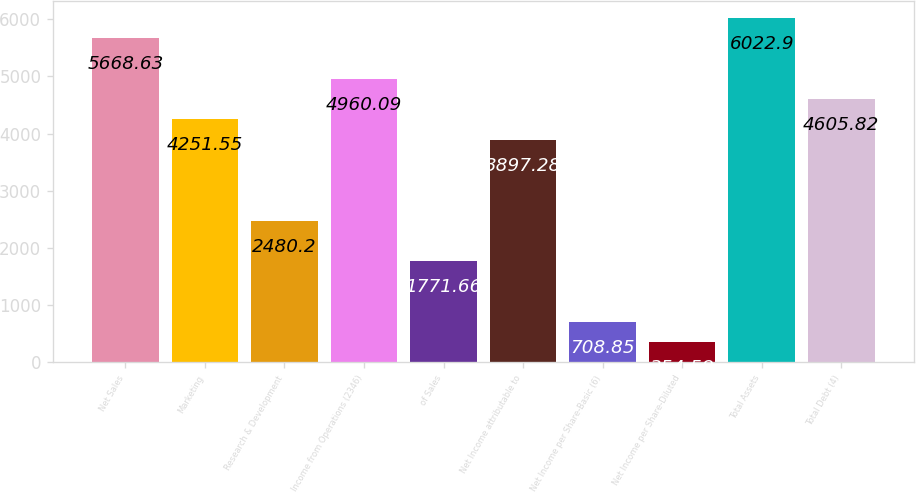<chart> <loc_0><loc_0><loc_500><loc_500><bar_chart><fcel>Net Sales<fcel>Marketing<fcel>Research & Development<fcel>Income from Operations (2346)<fcel>of Sales<fcel>Net Income attributable to<fcel>Net Income per Share-Basic (6)<fcel>Net Income per Share-Diluted<fcel>Total Assets<fcel>Total Debt (4)<nl><fcel>5668.63<fcel>4251.55<fcel>2480.2<fcel>4960.09<fcel>1771.66<fcel>3897.28<fcel>708.85<fcel>354.58<fcel>6022.9<fcel>4605.82<nl></chart> 